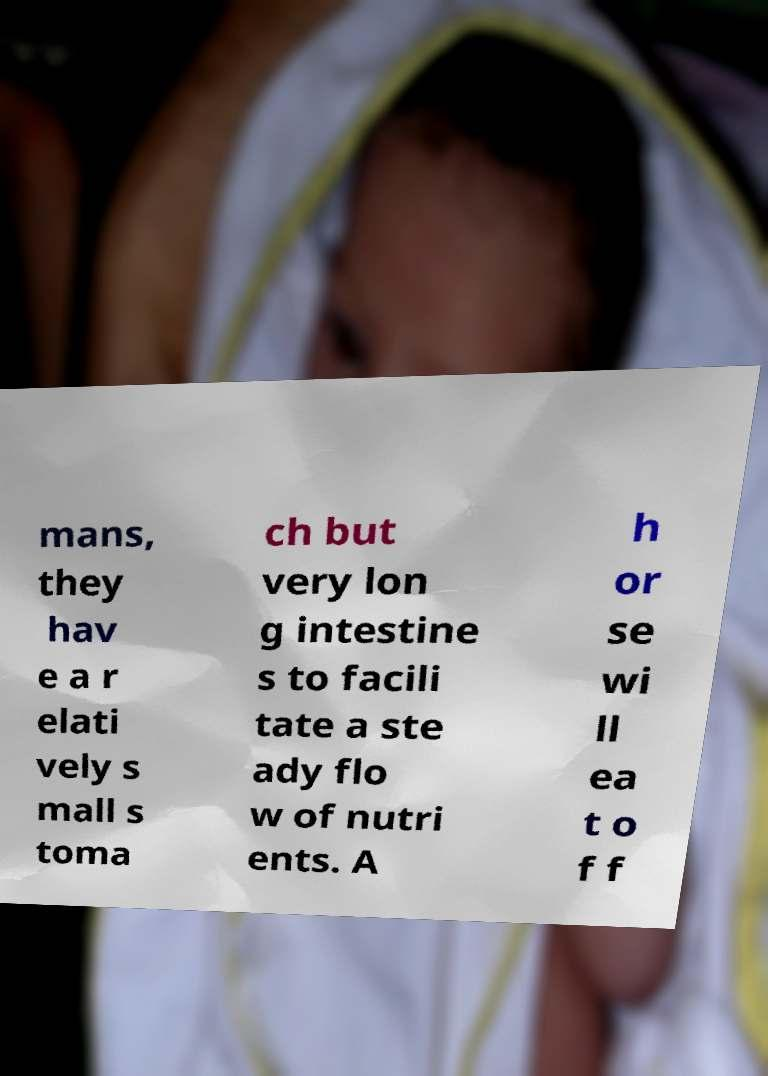Could you extract and type out the text from this image? mans, they hav e a r elati vely s mall s toma ch but very lon g intestine s to facili tate a ste ady flo w of nutri ents. A h or se wi ll ea t o f f 